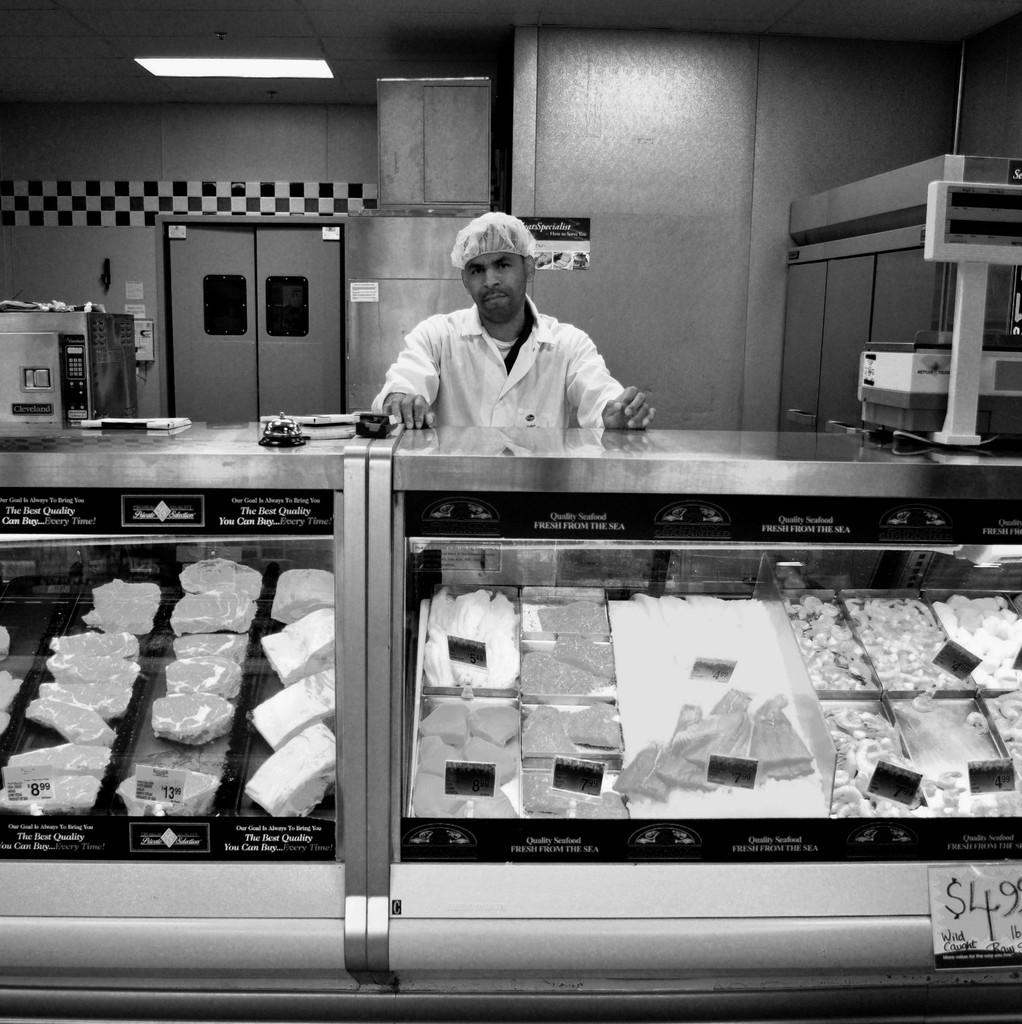<image>
Summarize the visual content of the image. A butcher stands behind the counter with a pricetag stating $4.99 per pound for some meat. 